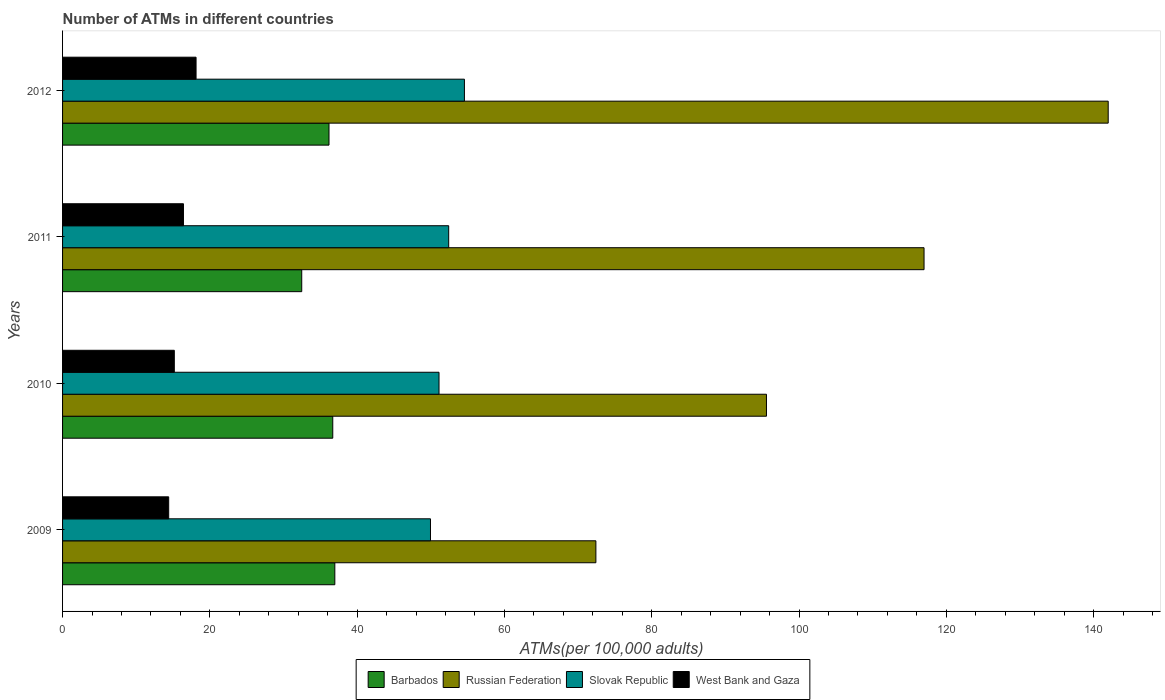How many different coloured bars are there?
Keep it short and to the point. 4. How many groups of bars are there?
Give a very brief answer. 4. Are the number of bars per tick equal to the number of legend labels?
Offer a terse response. Yes. How many bars are there on the 2nd tick from the top?
Offer a very short reply. 4. How many bars are there on the 3rd tick from the bottom?
Provide a succinct answer. 4. In how many cases, is the number of bars for a given year not equal to the number of legend labels?
Offer a terse response. 0. What is the number of ATMs in Barbados in 2009?
Offer a terse response. 36.97. Across all years, what is the maximum number of ATMs in Slovak Republic?
Your answer should be very brief. 54.57. Across all years, what is the minimum number of ATMs in Barbados?
Provide a succinct answer. 32.47. In which year was the number of ATMs in Russian Federation minimum?
Make the answer very short. 2009. What is the total number of ATMs in Slovak Republic in the graph?
Make the answer very short. 208.07. What is the difference between the number of ATMs in Slovak Republic in 2009 and that in 2011?
Keep it short and to the point. -2.47. What is the difference between the number of ATMs in Slovak Republic in 2009 and the number of ATMs in Barbados in 2012?
Offer a terse response. 13.78. What is the average number of ATMs in Russian Federation per year?
Offer a very short reply. 106.74. In the year 2009, what is the difference between the number of ATMs in Barbados and number of ATMs in Slovak Republic?
Give a very brief answer. -12.99. What is the ratio of the number of ATMs in Barbados in 2009 to that in 2010?
Offer a very short reply. 1.01. Is the number of ATMs in Barbados in 2011 less than that in 2012?
Provide a short and direct response. Yes. What is the difference between the highest and the second highest number of ATMs in Slovak Republic?
Give a very brief answer. 2.14. What is the difference between the highest and the lowest number of ATMs in Russian Federation?
Make the answer very short. 69.56. In how many years, is the number of ATMs in Slovak Republic greater than the average number of ATMs in Slovak Republic taken over all years?
Keep it short and to the point. 2. Is the sum of the number of ATMs in Russian Federation in 2010 and 2011 greater than the maximum number of ATMs in Slovak Republic across all years?
Make the answer very short. Yes. What does the 4th bar from the top in 2009 represents?
Your answer should be compact. Barbados. What does the 3rd bar from the bottom in 2010 represents?
Keep it short and to the point. Slovak Republic. How many bars are there?
Ensure brevity in your answer.  16. Are all the bars in the graph horizontal?
Give a very brief answer. Yes. What is the difference between two consecutive major ticks on the X-axis?
Provide a succinct answer. 20. Are the values on the major ticks of X-axis written in scientific E-notation?
Ensure brevity in your answer.  No. What is the title of the graph?
Your response must be concise. Number of ATMs in different countries. What is the label or title of the X-axis?
Your response must be concise. ATMs(per 100,0 adults). What is the ATMs(per 100,000 adults) of Barbados in 2009?
Provide a succinct answer. 36.97. What is the ATMs(per 100,000 adults) of Russian Federation in 2009?
Offer a very short reply. 72.42. What is the ATMs(per 100,000 adults) in Slovak Republic in 2009?
Provide a succinct answer. 49.96. What is the ATMs(per 100,000 adults) of West Bank and Gaza in 2009?
Make the answer very short. 14.41. What is the ATMs(per 100,000 adults) of Barbados in 2010?
Provide a succinct answer. 36.69. What is the ATMs(per 100,000 adults) in Russian Federation in 2010?
Your response must be concise. 95.58. What is the ATMs(per 100,000 adults) in Slovak Republic in 2010?
Provide a succinct answer. 51.12. What is the ATMs(per 100,000 adults) of West Bank and Gaza in 2010?
Give a very brief answer. 15.17. What is the ATMs(per 100,000 adults) of Barbados in 2011?
Your response must be concise. 32.47. What is the ATMs(per 100,000 adults) in Russian Federation in 2011?
Give a very brief answer. 116.98. What is the ATMs(per 100,000 adults) in Slovak Republic in 2011?
Keep it short and to the point. 52.43. What is the ATMs(per 100,000 adults) in West Bank and Gaza in 2011?
Ensure brevity in your answer.  16.42. What is the ATMs(per 100,000 adults) of Barbados in 2012?
Your answer should be very brief. 36.18. What is the ATMs(per 100,000 adults) in Russian Federation in 2012?
Ensure brevity in your answer.  141.98. What is the ATMs(per 100,000 adults) of Slovak Republic in 2012?
Your response must be concise. 54.57. What is the ATMs(per 100,000 adults) in West Bank and Gaza in 2012?
Provide a short and direct response. 18.13. Across all years, what is the maximum ATMs(per 100,000 adults) in Barbados?
Offer a very short reply. 36.97. Across all years, what is the maximum ATMs(per 100,000 adults) of Russian Federation?
Offer a terse response. 141.98. Across all years, what is the maximum ATMs(per 100,000 adults) in Slovak Republic?
Provide a short and direct response. 54.57. Across all years, what is the maximum ATMs(per 100,000 adults) in West Bank and Gaza?
Offer a very short reply. 18.13. Across all years, what is the minimum ATMs(per 100,000 adults) in Barbados?
Your answer should be compact. 32.47. Across all years, what is the minimum ATMs(per 100,000 adults) in Russian Federation?
Your answer should be very brief. 72.42. Across all years, what is the minimum ATMs(per 100,000 adults) in Slovak Republic?
Keep it short and to the point. 49.96. Across all years, what is the minimum ATMs(per 100,000 adults) in West Bank and Gaza?
Provide a short and direct response. 14.41. What is the total ATMs(per 100,000 adults) in Barbados in the graph?
Offer a very short reply. 142.31. What is the total ATMs(per 100,000 adults) in Russian Federation in the graph?
Provide a succinct answer. 426.95. What is the total ATMs(per 100,000 adults) in Slovak Republic in the graph?
Make the answer very short. 208.07. What is the total ATMs(per 100,000 adults) in West Bank and Gaza in the graph?
Provide a short and direct response. 64.13. What is the difference between the ATMs(per 100,000 adults) of Barbados in 2009 and that in 2010?
Your response must be concise. 0.28. What is the difference between the ATMs(per 100,000 adults) of Russian Federation in 2009 and that in 2010?
Give a very brief answer. -23.16. What is the difference between the ATMs(per 100,000 adults) of Slovak Republic in 2009 and that in 2010?
Offer a terse response. -1.16. What is the difference between the ATMs(per 100,000 adults) in West Bank and Gaza in 2009 and that in 2010?
Provide a succinct answer. -0.76. What is the difference between the ATMs(per 100,000 adults) in Barbados in 2009 and that in 2011?
Keep it short and to the point. 4.49. What is the difference between the ATMs(per 100,000 adults) of Russian Federation in 2009 and that in 2011?
Your answer should be compact. -44.56. What is the difference between the ATMs(per 100,000 adults) of Slovak Republic in 2009 and that in 2011?
Your answer should be compact. -2.47. What is the difference between the ATMs(per 100,000 adults) of West Bank and Gaza in 2009 and that in 2011?
Give a very brief answer. -2.01. What is the difference between the ATMs(per 100,000 adults) in Barbados in 2009 and that in 2012?
Your answer should be very brief. 0.79. What is the difference between the ATMs(per 100,000 adults) in Russian Federation in 2009 and that in 2012?
Provide a short and direct response. -69.56. What is the difference between the ATMs(per 100,000 adults) in Slovak Republic in 2009 and that in 2012?
Give a very brief answer. -4.61. What is the difference between the ATMs(per 100,000 adults) in West Bank and Gaza in 2009 and that in 2012?
Your answer should be very brief. -3.72. What is the difference between the ATMs(per 100,000 adults) of Barbados in 2010 and that in 2011?
Make the answer very short. 4.21. What is the difference between the ATMs(per 100,000 adults) in Russian Federation in 2010 and that in 2011?
Provide a succinct answer. -21.4. What is the difference between the ATMs(per 100,000 adults) of Slovak Republic in 2010 and that in 2011?
Your answer should be very brief. -1.31. What is the difference between the ATMs(per 100,000 adults) in West Bank and Gaza in 2010 and that in 2011?
Provide a short and direct response. -1.24. What is the difference between the ATMs(per 100,000 adults) in Barbados in 2010 and that in 2012?
Provide a succinct answer. 0.51. What is the difference between the ATMs(per 100,000 adults) of Russian Federation in 2010 and that in 2012?
Provide a short and direct response. -46.4. What is the difference between the ATMs(per 100,000 adults) of Slovak Republic in 2010 and that in 2012?
Your answer should be compact. -3.45. What is the difference between the ATMs(per 100,000 adults) in West Bank and Gaza in 2010 and that in 2012?
Your response must be concise. -2.95. What is the difference between the ATMs(per 100,000 adults) of Barbados in 2011 and that in 2012?
Your answer should be compact. -3.7. What is the difference between the ATMs(per 100,000 adults) in Russian Federation in 2011 and that in 2012?
Your response must be concise. -25.01. What is the difference between the ATMs(per 100,000 adults) of Slovak Republic in 2011 and that in 2012?
Make the answer very short. -2.14. What is the difference between the ATMs(per 100,000 adults) in West Bank and Gaza in 2011 and that in 2012?
Your response must be concise. -1.71. What is the difference between the ATMs(per 100,000 adults) in Barbados in 2009 and the ATMs(per 100,000 adults) in Russian Federation in 2010?
Your answer should be compact. -58.61. What is the difference between the ATMs(per 100,000 adults) in Barbados in 2009 and the ATMs(per 100,000 adults) in Slovak Republic in 2010?
Offer a very short reply. -14.15. What is the difference between the ATMs(per 100,000 adults) of Barbados in 2009 and the ATMs(per 100,000 adults) of West Bank and Gaza in 2010?
Keep it short and to the point. 21.79. What is the difference between the ATMs(per 100,000 adults) of Russian Federation in 2009 and the ATMs(per 100,000 adults) of Slovak Republic in 2010?
Provide a succinct answer. 21.3. What is the difference between the ATMs(per 100,000 adults) in Russian Federation in 2009 and the ATMs(per 100,000 adults) in West Bank and Gaza in 2010?
Offer a very short reply. 57.24. What is the difference between the ATMs(per 100,000 adults) in Slovak Republic in 2009 and the ATMs(per 100,000 adults) in West Bank and Gaza in 2010?
Make the answer very short. 34.78. What is the difference between the ATMs(per 100,000 adults) in Barbados in 2009 and the ATMs(per 100,000 adults) in Russian Federation in 2011?
Give a very brief answer. -80.01. What is the difference between the ATMs(per 100,000 adults) in Barbados in 2009 and the ATMs(per 100,000 adults) in Slovak Republic in 2011?
Your answer should be compact. -15.46. What is the difference between the ATMs(per 100,000 adults) of Barbados in 2009 and the ATMs(per 100,000 adults) of West Bank and Gaza in 2011?
Your answer should be compact. 20.55. What is the difference between the ATMs(per 100,000 adults) in Russian Federation in 2009 and the ATMs(per 100,000 adults) in Slovak Republic in 2011?
Keep it short and to the point. 19.99. What is the difference between the ATMs(per 100,000 adults) in Russian Federation in 2009 and the ATMs(per 100,000 adults) in West Bank and Gaza in 2011?
Provide a short and direct response. 56. What is the difference between the ATMs(per 100,000 adults) of Slovak Republic in 2009 and the ATMs(per 100,000 adults) of West Bank and Gaza in 2011?
Your answer should be compact. 33.54. What is the difference between the ATMs(per 100,000 adults) of Barbados in 2009 and the ATMs(per 100,000 adults) of Russian Federation in 2012?
Provide a short and direct response. -105.01. What is the difference between the ATMs(per 100,000 adults) of Barbados in 2009 and the ATMs(per 100,000 adults) of Slovak Republic in 2012?
Provide a succinct answer. -17.6. What is the difference between the ATMs(per 100,000 adults) in Barbados in 2009 and the ATMs(per 100,000 adults) in West Bank and Gaza in 2012?
Your answer should be compact. 18.84. What is the difference between the ATMs(per 100,000 adults) of Russian Federation in 2009 and the ATMs(per 100,000 adults) of Slovak Republic in 2012?
Ensure brevity in your answer.  17.85. What is the difference between the ATMs(per 100,000 adults) of Russian Federation in 2009 and the ATMs(per 100,000 adults) of West Bank and Gaza in 2012?
Offer a very short reply. 54.29. What is the difference between the ATMs(per 100,000 adults) of Slovak Republic in 2009 and the ATMs(per 100,000 adults) of West Bank and Gaza in 2012?
Offer a very short reply. 31.83. What is the difference between the ATMs(per 100,000 adults) in Barbados in 2010 and the ATMs(per 100,000 adults) in Russian Federation in 2011?
Make the answer very short. -80.29. What is the difference between the ATMs(per 100,000 adults) of Barbados in 2010 and the ATMs(per 100,000 adults) of Slovak Republic in 2011?
Offer a very short reply. -15.74. What is the difference between the ATMs(per 100,000 adults) of Barbados in 2010 and the ATMs(per 100,000 adults) of West Bank and Gaza in 2011?
Your response must be concise. 20.27. What is the difference between the ATMs(per 100,000 adults) in Russian Federation in 2010 and the ATMs(per 100,000 adults) in Slovak Republic in 2011?
Make the answer very short. 43.15. What is the difference between the ATMs(per 100,000 adults) of Russian Federation in 2010 and the ATMs(per 100,000 adults) of West Bank and Gaza in 2011?
Offer a very short reply. 79.16. What is the difference between the ATMs(per 100,000 adults) of Slovak Republic in 2010 and the ATMs(per 100,000 adults) of West Bank and Gaza in 2011?
Your response must be concise. 34.7. What is the difference between the ATMs(per 100,000 adults) of Barbados in 2010 and the ATMs(per 100,000 adults) of Russian Federation in 2012?
Ensure brevity in your answer.  -105.29. What is the difference between the ATMs(per 100,000 adults) of Barbados in 2010 and the ATMs(per 100,000 adults) of Slovak Republic in 2012?
Make the answer very short. -17.88. What is the difference between the ATMs(per 100,000 adults) in Barbados in 2010 and the ATMs(per 100,000 adults) in West Bank and Gaza in 2012?
Ensure brevity in your answer.  18.56. What is the difference between the ATMs(per 100,000 adults) in Russian Federation in 2010 and the ATMs(per 100,000 adults) in Slovak Republic in 2012?
Provide a succinct answer. 41.01. What is the difference between the ATMs(per 100,000 adults) of Russian Federation in 2010 and the ATMs(per 100,000 adults) of West Bank and Gaza in 2012?
Give a very brief answer. 77.45. What is the difference between the ATMs(per 100,000 adults) of Slovak Republic in 2010 and the ATMs(per 100,000 adults) of West Bank and Gaza in 2012?
Provide a short and direct response. 32.99. What is the difference between the ATMs(per 100,000 adults) in Barbados in 2011 and the ATMs(per 100,000 adults) in Russian Federation in 2012?
Your response must be concise. -109.51. What is the difference between the ATMs(per 100,000 adults) of Barbados in 2011 and the ATMs(per 100,000 adults) of Slovak Republic in 2012?
Provide a succinct answer. -22.09. What is the difference between the ATMs(per 100,000 adults) of Barbados in 2011 and the ATMs(per 100,000 adults) of West Bank and Gaza in 2012?
Provide a succinct answer. 14.35. What is the difference between the ATMs(per 100,000 adults) in Russian Federation in 2011 and the ATMs(per 100,000 adults) in Slovak Republic in 2012?
Make the answer very short. 62.41. What is the difference between the ATMs(per 100,000 adults) in Russian Federation in 2011 and the ATMs(per 100,000 adults) in West Bank and Gaza in 2012?
Provide a succinct answer. 98.85. What is the difference between the ATMs(per 100,000 adults) in Slovak Republic in 2011 and the ATMs(per 100,000 adults) in West Bank and Gaza in 2012?
Offer a terse response. 34.3. What is the average ATMs(per 100,000 adults) of Barbados per year?
Make the answer very short. 35.58. What is the average ATMs(per 100,000 adults) in Russian Federation per year?
Keep it short and to the point. 106.74. What is the average ATMs(per 100,000 adults) of Slovak Republic per year?
Offer a very short reply. 52.02. What is the average ATMs(per 100,000 adults) in West Bank and Gaza per year?
Offer a very short reply. 16.03. In the year 2009, what is the difference between the ATMs(per 100,000 adults) of Barbados and ATMs(per 100,000 adults) of Russian Federation?
Offer a terse response. -35.45. In the year 2009, what is the difference between the ATMs(per 100,000 adults) of Barbados and ATMs(per 100,000 adults) of Slovak Republic?
Offer a very short reply. -12.99. In the year 2009, what is the difference between the ATMs(per 100,000 adults) of Barbados and ATMs(per 100,000 adults) of West Bank and Gaza?
Offer a terse response. 22.56. In the year 2009, what is the difference between the ATMs(per 100,000 adults) in Russian Federation and ATMs(per 100,000 adults) in Slovak Republic?
Your response must be concise. 22.46. In the year 2009, what is the difference between the ATMs(per 100,000 adults) of Russian Federation and ATMs(per 100,000 adults) of West Bank and Gaza?
Ensure brevity in your answer.  58.01. In the year 2009, what is the difference between the ATMs(per 100,000 adults) of Slovak Republic and ATMs(per 100,000 adults) of West Bank and Gaza?
Your response must be concise. 35.55. In the year 2010, what is the difference between the ATMs(per 100,000 adults) of Barbados and ATMs(per 100,000 adults) of Russian Federation?
Provide a short and direct response. -58.89. In the year 2010, what is the difference between the ATMs(per 100,000 adults) in Barbados and ATMs(per 100,000 adults) in Slovak Republic?
Offer a terse response. -14.43. In the year 2010, what is the difference between the ATMs(per 100,000 adults) of Barbados and ATMs(per 100,000 adults) of West Bank and Gaza?
Offer a very short reply. 21.51. In the year 2010, what is the difference between the ATMs(per 100,000 adults) of Russian Federation and ATMs(per 100,000 adults) of Slovak Republic?
Offer a very short reply. 44.46. In the year 2010, what is the difference between the ATMs(per 100,000 adults) in Russian Federation and ATMs(per 100,000 adults) in West Bank and Gaza?
Your response must be concise. 80.4. In the year 2010, what is the difference between the ATMs(per 100,000 adults) in Slovak Republic and ATMs(per 100,000 adults) in West Bank and Gaza?
Your answer should be compact. 35.94. In the year 2011, what is the difference between the ATMs(per 100,000 adults) in Barbados and ATMs(per 100,000 adults) in Russian Federation?
Give a very brief answer. -84.5. In the year 2011, what is the difference between the ATMs(per 100,000 adults) in Barbados and ATMs(per 100,000 adults) in Slovak Republic?
Make the answer very short. -19.95. In the year 2011, what is the difference between the ATMs(per 100,000 adults) in Barbados and ATMs(per 100,000 adults) in West Bank and Gaza?
Your answer should be compact. 16.06. In the year 2011, what is the difference between the ATMs(per 100,000 adults) of Russian Federation and ATMs(per 100,000 adults) of Slovak Republic?
Offer a very short reply. 64.55. In the year 2011, what is the difference between the ATMs(per 100,000 adults) of Russian Federation and ATMs(per 100,000 adults) of West Bank and Gaza?
Your response must be concise. 100.56. In the year 2011, what is the difference between the ATMs(per 100,000 adults) in Slovak Republic and ATMs(per 100,000 adults) in West Bank and Gaza?
Your response must be concise. 36.01. In the year 2012, what is the difference between the ATMs(per 100,000 adults) in Barbados and ATMs(per 100,000 adults) in Russian Federation?
Your answer should be very brief. -105.8. In the year 2012, what is the difference between the ATMs(per 100,000 adults) in Barbados and ATMs(per 100,000 adults) in Slovak Republic?
Provide a succinct answer. -18.39. In the year 2012, what is the difference between the ATMs(per 100,000 adults) in Barbados and ATMs(per 100,000 adults) in West Bank and Gaza?
Offer a terse response. 18.05. In the year 2012, what is the difference between the ATMs(per 100,000 adults) of Russian Federation and ATMs(per 100,000 adults) of Slovak Republic?
Ensure brevity in your answer.  87.42. In the year 2012, what is the difference between the ATMs(per 100,000 adults) in Russian Federation and ATMs(per 100,000 adults) in West Bank and Gaza?
Provide a succinct answer. 123.85. In the year 2012, what is the difference between the ATMs(per 100,000 adults) of Slovak Republic and ATMs(per 100,000 adults) of West Bank and Gaza?
Offer a terse response. 36.44. What is the ratio of the ATMs(per 100,000 adults) in Barbados in 2009 to that in 2010?
Keep it short and to the point. 1.01. What is the ratio of the ATMs(per 100,000 adults) in Russian Federation in 2009 to that in 2010?
Make the answer very short. 0.76. What is the ratio of the ATMs(per 100,000 adults) in Slovak Republic in 2009 to that in 2010?
Your answer should be compact. 0.98. What is the ratio of the ATMs(per 100,000 adults) of West Bank and Gaza in 2009 to that in 2010?
Your answer should be compact. 0.95. What is the ratio of the ATMs(per 100,000 adults) in Barbados in 2009 to that in 2011?
Your answer should be compact. 1.14. What is the ratio of the ATMs(per 100,000 adults) in Russian Federation in 2009 to that in 2011?
Provide a short and direct response. 0.62. What is the ratio of the ATMs(per 100,000 adults) in Slovak Republic in 2009 to that in 2011?
Offer a very short reply. 0.95. What is the ratio of the ATMs(per 100,000 adults) in West Bank and Gaza in 2009 to that in 2011?
Your answer should be very brief. 0.88. What is the ratio of the ATMs(per 100,000 adults) of Barbados in 2009 to that in 2012?
Offer a terse response. 1.02. What is the ratio of the ATMs(per 100,000 adults) in Russian Federation in 2009 to that in 2012?
Make the answer very short. 0.51. What is the ratio of the ATMs(per 100,000 adults) of Slovak Republic in 2009 to that in 2012?
Provide a short and direct response. 0.92. What is the ratio of the ATMs(per 100,000 adults) of West Bank and Gaza in 2009 to that in 2012?
Offer a terse response. 0.79. What is the ratio of the ATMs(per 100,000 adults) in Barbados in 2010 to that in 2011?
Your answer should be very brief. 1.13. What is the ratio of the ATMs(per 100,000 adults) in Russian Federation in 2010 to that in 2011?
Provide a short and direct response. 0.82. What is the ratio of the ATMs(per 100,000 adults) in Slovak Republic in 2010 to that in 2011?
Give a very brief answer. 0.97. What is the ratio of the ATMs(per 100,000 adults) in West Bank and Gaza in 2010 to that in 2011?
Offer a terse response. 0.92. What is the ratio of the ATMs(per 100,000 adults) in Barbados in 2010 to that in 2012?
Offer a terse response. 1.01. What is the ratio of the ATMs(per 100,000 adults) in Russian Federation in 2010 to that in 2012?
Offer a terse response. 0.67. What is the ratio of the ATMs(per 100,000 adults) in Slovak Republic in 2010 to that in 2012?
Offer a very short reply. 0.94. What is the ratio of the ATMs(per 100,000 adults) in West Bank and Gaza in 2010 to that in 2012?
Provide a short and direct response. 0.84. What is the ratio of the ATMs(per 100,000 adults) of Barbados in 2011 to that in 2012?
Provide a succinct answer. 0.9. What is the ratio of the ATMs(per 100,000 adults) of Russian Federation in 2011 to that in 2012?
Give a very brief answer. 0.82. What is the ratio of the ATMs(per 100,000 adults) in Slovak Republic in 2011 to that in 2012?
Make the answer very short. 0.96. What is the ratio of the ATMs(per 100,000 adults) of West Bank and Gaza in 2011 to that in 2012?
Your answer should be compact. 0.91. What is the difference between the highest and the second highest ATMs(per 100,000 adults) in Barbados?
Ensure brevity in your answer.  0.28. What is the difference between the highest and the second highest ATMs(per 100,000 adults) in Russian Federation?
Your answer should be very brief. 25.01. What is the difference between the highest and the second highest ATMs(per 100,000 adults) of Slovak Republic?
Give a very brief answer. 2.14. What is the difference between the highest and the second highest ATMs(per 100,000 adults) in West Bank and Gaza?
Give a very brief answer. 1.71. What is the difference between the highest and the lowest ATMs(per 100,000 adults) of Barbados?
Ensure brevity in your answer.  4.49. What is the difference between the highest and the lowest ATMs(per 100,000 adults) in Russian Federation?
Offer a very short reply. 69.56. What is the difference between the highest and the lowest ATMs(per 100,000 adults) in Slovak Republic?
Your response must be concise. 4.61. What is the difference between the highest and the lowest ATMs(per 100,000 adults) of West Bank and Gaza?
Provide a short and direct response. 3.72. 